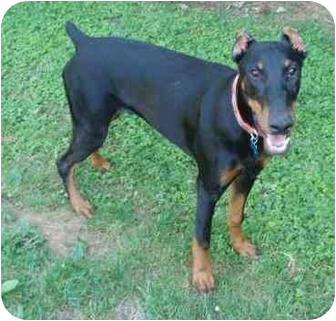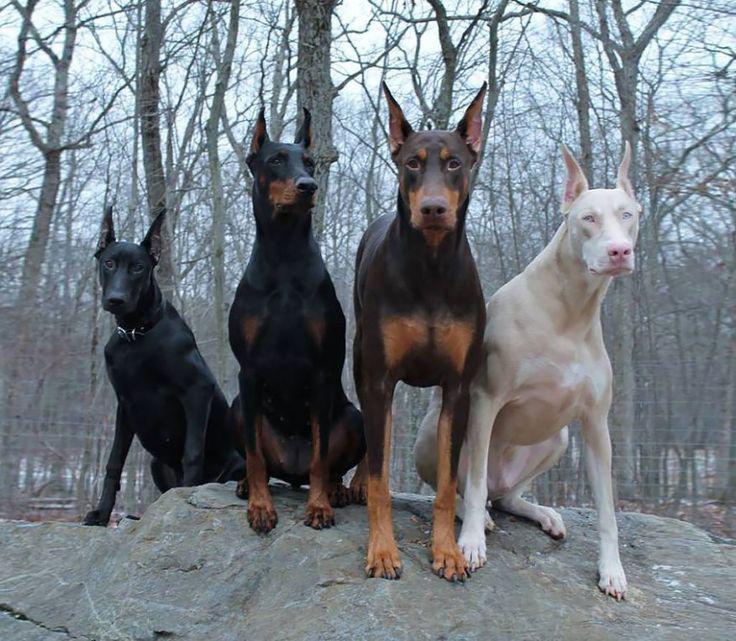The first image is the image on the left, the second image is the image on the right. Given the left and right images, does the statement "One image shows a camera-gazing doberman with a blue tag dangling from its collar and stubby-looking ears." hold true? Answer yes or no. Yes. The first image is the image on the left, the second image is the image on the right. Assess this claim about the two images: "There are two dogs.". Correct or not? Answer yes or no. No. 